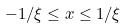<formula> <loc_0><loc_0><loc_500><loc_500>- 1 / \xi \leq x \leq 1 / \xi</formula> 